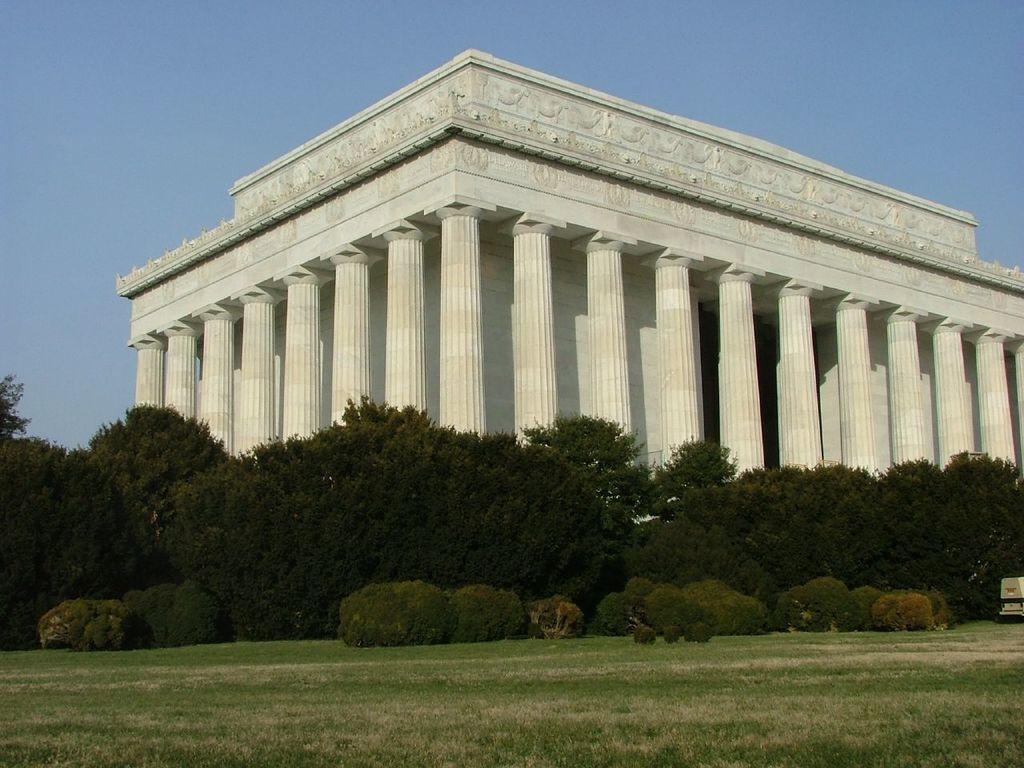Describe this image in one or two sentences. In this image, we can see a building. There are some trees and plants in the middle of the image. There is a grass on the ground. In the background of the image, there is a sky. 